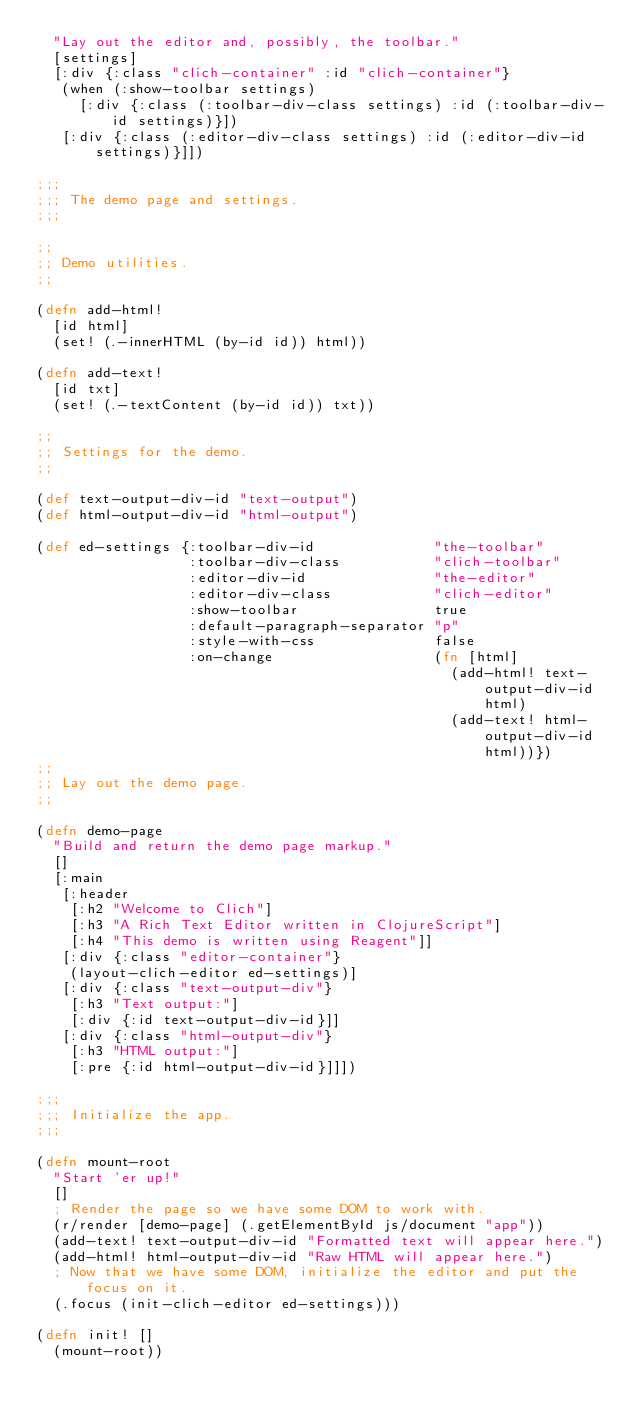<code> <loc_0><loc_0><loc_500><loc_500><_Clojure_>  "Lay out the editor and, possibly, the toolbar."
  [settings]
  [:div {:class "clich-container" :id "clich-container"}
   (when (:show-toolbar settings)
     [:div {:class (:toolbar-div-class settings) :id (:toolbar-div-id settings)}])
   [:div {:class (:editor-div-class settings) :id (:editor-div-id settings)}]])

;;;
;;; The demo page and settings.
;;;

;;
;; Demo utilities.
;;

(defn add-html!
  [id html]
  (set! (.-innerHTML (by-id id)) html))

(defn add-text!
  [id txt]
  (set! (.-textContent (by-id id)) txt))

;;
;; Settings for the demo.
;;

(def text-output-div-id "text-output")
(def html-output-div-id "html-output")

(def ed-settings {:toolbar-div-id              "the-toolbar"
                  :toolbar-div-class           "clich-toolbar"
                  :editor-div-id               "the-editor"
                  :editor-div-class            "clich-editor"
                  :show-toolbar                true
                  :default-paragraph-separator "p"
                  :style-with-css              false
                  :on-change                   (fn [html]
                                                 (add-html! text-output-div-id html)
                                                 (add-text! html-output-div-id html))})
;;
;; Lay out the demo page.
;;

(defn demo-page
  "Build and return the demo page markup."
  []
  [:main
   [:header
    [:h2 "Welcome to Clich"]
    [:h3 "A Rich Text Editor written in ClojureScript"]
    [:h4 "This demo is written using Reagent"]]
   [:div {:class "editor-container"}
    (layout-clich-editor ed-settings)]
   [:div {:class "text-output-div"}
    [:h3 "Text output:"]
    [:div {:id text-output-div-id}]]
   [:div {:class "html-output-div"}
    [:h3 "HTML output:"]
    [:pre {:id html-output-div-id}]]])

;;;
;;; Initialize the app.
;;;

(defn mount-root
  "Start 'er up!"
  []
  ; Render the page so we have some DOM to work with.
  (r/render [demo-page] (.getElementById js/document "app"))
  (add-text! text-output-div-id "Formatted text will appear here.")
  (add-html! html-output-div-id "Raw HTML will appear here.")
  ; Now that we have some DOM, initialize the editor and put the focus on it.
  (.focus (init-clich-editor ed-settings)))

(defn init! []
  (mount-root))
</code> 